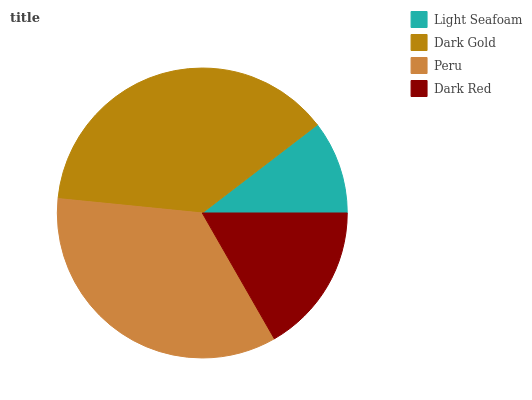Is Light Seafoam the minimum?
Answer yes or no. Yes. Is Dark Gold the maximum?
Answer yes or no. Yes. Is Peru the minimum?
Answer yes or no. No. Is Peru the maximum?
Answer yes or no. No. Is Dark Gold greater than Peru?
Answer yes or no. Yes. Is Peru less than Dark Gold?
Answer yes or no. Yes. Is Peru greater than Dark Gold?
Answer yes or no. No. Is Dark Gold less than Peru?
Answer yes or no. No. Is Peru the high median?
Answer yes or no. Yes. Is Dark Red the low median?
Answer yes or no. Yes. Is Light Seafoam the high median?
Answer yes or no. No. Is Dark Gold the low median?
Answer yes or no. No. 